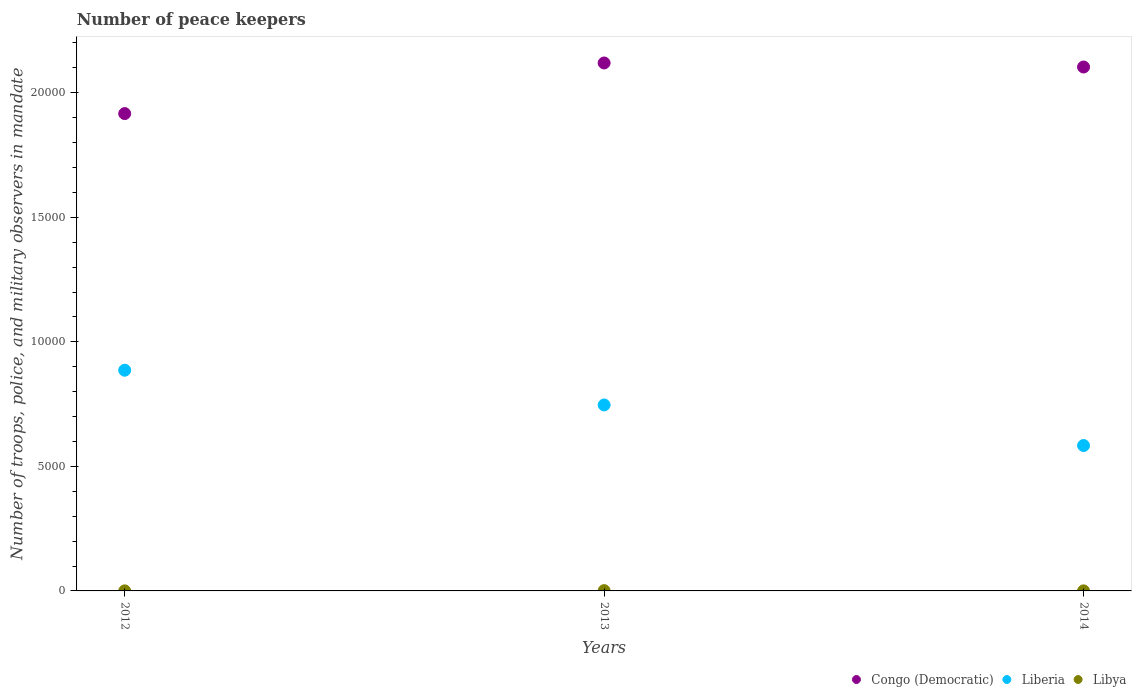What is the number of peace keepers in in Liberia in 2013?
Provide a short and direct response. 7467. Across all years, what is the maximum number of peace keepers in in Congo (Democratic)?
Make the answer very short. 2.12e+04. Across all years, what is the minimum number of peace keepers in in Congo (Democratic)?
Your answer should be compact. 1.92e+04. What is the difference between the number of peace keepers in in Congo (Democratic) in 2012 and that in 2013?
Provide a short and direct response. -2032. What is the difference between the number of peace keepers in in Congo (Democratic) in 2014 and the number of peace keepers in in Libya in 2012?
Offer a very short reply. 2.10e+04. What is the average number of peace keepers in in Libya per year?
Keep it short and to the point. 5. In the year 2014, what is the difference between the number of peace keepers in in Libya and number of peace keepers in in Liberia?
Your answer should be very brief. -5836. In how many years, is the number of peace keepers in in Libya greater than 16000?
Make the answer very short. 0. What is the difference between the highest and the second highest number of peace keepers in in Congo (Democratic)?
Keep it short and to the point. 162. What is the difference between the highest and the lowest number of peace keepers in in Congo (Democratic)?
Keep it short and to the point. 2032. In how many years, is the number of peace keepers in in Liberia greater than the average number of peace keepers in in Liberia taken over all years?
Make the answer very short. 2. Is the sum of the number of peace keepers in in Libya in 2013 and 2014 greater than the maximum number of peace keepers in in Liberia across all years?
Ensure brevity in your answer.  No. Is the number of peace keepers in in Congo (Democratic) strictly less than the number of peace keepers in in Liberia over the years?
Keep it short and to the point. No. What is the difference between two consecutive major ticks on the Y-axis?
Make the answer very short. 5000. Are the values on the major ticks of Y-axis written in scientific E-notation?
Ensure brevity in your answer.  No. Does the graph contain any zero values?
Ensure brevity in your answer.  No. Does the graph contain grids?
Your response must be concise. No. What is the title of the graph?
Provide a succinct answer. Number of peace keepers. What is the label or title of the Y-axis?
Your response must be concise. Number of troops, police, and military observers in mandate. What is the Number of troops, police, and military observers in mandate in Congo (Democratic) in 2012?
Your response must be concise. 1.92e+04. What is the Number of troops, police, and military observers in mandate in Liberia in 2012?
Make the answer very short. 8862. What is the Number of troops, police, and military observers in mandate in Congo (Democratic) in 2013?
Provide a short and direct response. 2.12e+04. What is the Number of troops, police, and military observers in mandate of Liberia in 2013?
Keep it short and to the point. 7467. What is the Number of troops, police, and military observers in mandate in Congo (Democratic) in 2014?
Your answer should be very brief. 2.10e+04. What is the Number of troops, police, and military observers in mandate of Liberia in 2014?
Your answer should be compact. 5838. Across all years, what is the maximum Number of troops, police, and military observers in mandate in Congo (Democratic)?
Keep it short and to the point. 2.12e+04. Across all years, what is the maximum Number of troops, police, and military observers in mandate of Liberia?
Your response must be concise. 8862. Across all years, what is the maximum Number of troops, police, and military observers in mandate in Libya?
Your answer should be very brief. 11. Across all years, what is the minimum Number of troops, police, and military observers in mandate in Congo (Democratic)?
Your answer should be compact. 1.92e+04. Across all years, what is the minimum Number of troops, police, and military observers in mandate in Liberia?
Offer a very short reply. 5838. Across all years, what is the minimum Number of troops, police, and military observers in mandate in Libya?
Provide a succinct answer. 2. What is the total Number of troops, police, and military observers in mandate of Congo (Democratic) in the graph?
Ensure brevity in your answer.  6.14e+04. What is the total Number of troops, police, and military observers in mandate of Liberia in the graph?
Give a very brief answer. 2.22e+04. What is the total Number of troops, police, and military observers in mandate in Libya in the graph?
Provide a short and direct response. 15. What is the difference between the Number of troops, police, and military observers in mandate of Congo (Democratic) in 2012 and that in 2013?
Your answer should be very brief. -2032. What is the difference between the Number of troops, police, and military observers in mandate in Liberia in 2012 and that in 2013?
Your answer should be compact. 1395. What is the difference between the Number of troops, police, and military observers in mandate of Congo (Democratic) in 2012 and that in 2014?
Your response must be concise. -1870. What is the difference between the Number of troops, police, and military observers in mandate of Liberia in 2012 and that in 2014?
Offer a terse response. 3024. What is the difference between the Number of troops, police, and military observers in mandate in Congo (Democratic) in 2013 and that in 2014?
Provide a succinct answer. 162. What is the difference between the Number of troops, police, and military observers in mandate in Liberia in 2013 and that in 2014?
Your answer should be very brief. 1629. What is the difference between the Number of troops, police, and military observers in mandate in Congo (Democratic) in 2012 and the Number of troops, police, and military observers in mandate in Liberia in 2013?
Provide a succinct answer. 1.17e+04. What is the difference between the Number of troops, police, and military observers in mandate of Congo (Democratic) in 2012 and the Number of troops, police, and military observers in mandate of Libya in 2013?
Your answer should be compact. 1.92e+04. What is the difference between the Number of troops, police, and military observers in mandate in Liberia in 2012 and the Number of troops, police, and military observers in mandate in Libya in 2013?
Make the answer very short. 8851. What is the difference between the Number of troops, police, and military observers in mandate in Congo (Democratic) in 2012 and the Number of troops, police, and military observers in mandate in Liberia in 2014?
Your answer should be very brief. 1.33e+04. What is the difference between the Number of troops, police, and military observers in mandate in Congo (Democratic) in 2012 and the Number of troops, police, and military observers in mandate in Libya in 2014?
Give a very brief answer. 1.92e+04. What is the difference between the Number of troops, police, and military observers in mandate of Liberia in 2012 and the Number of troops, police, and military observers in mandate of Libya in 2014?
Your answer should be very brief. 8860. What is the difference between the Number of troops, police, and military observers in mandate in Congo (Democratic) in 2013 and the Number of troops, police, and military observers in mandate in Liberia in 2014?
Your response must be concise. 1.54e+04. What is the difference between the Number of troops, police, and military observers in mandate in Congo (Democratic) in 2013 and the Number of troops, police, and military observers in mandate in Libya in 2014?
Your answer should be compact. 2.12e+04. What is the difference between the Number of troops, police, and military observers in mandate of Liberia in 2013 and the Number of troops, police, and military observers in mandate of Libya in 2014?
Your answer should be compact. 7465. What is the average Number of troops, police, and military observers in mandate of Congo (Democratic) per year?
Your answer should be compact. 2.05e+04. What is the average Number of troops, police, and military observers in mandate in Liberia per year?
Give a very brief answer. 7389. In the year 2012, what is the difference between the Number of troops, police, and military observers in mandate in Congo (Democratic) and Number of troops, police, and military observers in mandate in Liberia?
Provide a succinct answer. 1.03e+04. In the year 2012, what is the difference between the Number of troops, police, and military observers in mandate of Congo (Democratic) and Number of troops, police, and military observers in mandate of Libya?
Give a very brief answer. 1.92e+04. In the year 2012, what is the difference between the Number of troops, police, and military observers in mandate of Liberia and Number of troops, police, and military observers in mandate of Libya?
Your answer should be very brief. 8860. In the year 2013, what is the difference between the Number of troops, police, and military observers in mandate of Congo (Democratic) and Number of troops, police, and military observers in mandate of Liberia?
Make the answer very short. 1.37e+04. In the year 2013, what is the difference between the Number of troops, police, and military observers in mandate in Congo (Democratic) and Number of troops, police, and military observers in mandate in Libya?
Give a very brief answer. 2.12e+04. In the year 2013, what is the difference between the Number of troops, police, and military observers in mandate of Liberia and Number of troops, police, and military observers in mandate of Libya?
Offer a very short reply. 7456. In the year 2014, what is the difference between the Number of troops, police, and military observers in mandate in Congo (Democratic) and Number of troops, police, and military observers in mandate in Liberia?
Your answer should be compact. 1.52e+04. In the year 2014, what is the difference between the Number of troops, police, and military observers in mandate in Congo (Democratic) and Number of troops, police, and military observers in mandate in Libya?
Provide a short and direct response. 2.10e+04. In the year 2014, what is the difference between the Number of troops, police, and military observers in mandate in Liberia and Number of troops, police, and military observers in mandate in Libya?
Offer a terse response. 5836. What is the ratio of the Number of troops, police, and military observers in mandate of Congo (Democratic) in 2012 to that in 2013?
Provide a succinct answer. 0.9. What is the ratio of the Number of troops, police, and military observers in mandate in Liberia in 2012 to that in 2013?
Ensure brevity in your answer.  1.19. What is the ratio of the Number of troops, police, and military observers in mandate in Libya in 2012 to that in 2013?
Keep it short and to the point. 0.18. What is the ratio of the Number of troops, police, and military observers in mandate in Congo (Democratic) in 2012 to that in 2014?
Your answer should be compact. 0.91. What is the ratio of the Number of troops, police, and military observers in mandate of Liberia in 2012 to that in 2014?
Your answer should be compact. 1.52. What is the ratio of the Number of troops, police, and military observers in mandate in Congo (Democratic) in 2013 to that in 2014?
Give a very brief answer. 1.01. What is the ratio of the Number of troops, police, and military observers in mandate in Liberia in 2013 to that in 2014?
Your answer should be very brief. 1.28. What is the difference between the highest and the second highest Number of troops, police, and military observers in mandate in Congo (Democratic)?
Ensure brevity in your answer.  162. What is the difference between the highest and the second highest Number of troops, police, and military observers in mandate of Liberia?
Keep it short and to the point. 1395. What is the difference between the highest and the second highest Number of troops, police, and military observers in mandate in Libya?
Give a very brief answer. 9. What is the difference between the highest and the lowest Number of troops, police, and military observers in mandate of Congo (Democratic)?
Your answer should be very brief. 2032. What is the difference between the highest and the lowest Number of troops, police, and military observers in mandate in Liberia?
Your answer should be very brief. 3024. What is the difference between the highest and the lowest Number of troops, police, and military observers in mandate in Libya?
Give a very brief answer. 9. 